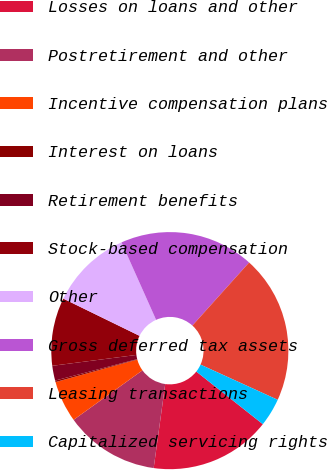Convert chart to OTSL. <chart><loc_0><loc_0><loc_500><loc_500><pie_chart><fcel>Losses on loans and other<fcel>Postretirement and other<fcel>Incentive compensation plans<fcel>Interest on loans<fcel>Retirement benefits<fcel>Stock-based compensation<fcel>Other<fcel>Gross deferred tax assets<fcel>Leasing transactions<fcel>Capitalized servicing rights<nl><fcel>16.53%<fcel>12.9%<fcel>5.65%<fcel>0.21%<fcel>2.02%<fcel>9.27%<fcel>11.09%<fcel>18.34%<fcel>20.15%<fcel>3.84%<nl></chart> 